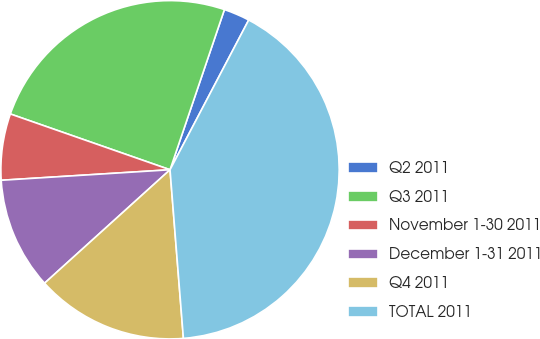<chart> <loc_0><loc_0><loc_500><loc_500><pie_chart><fcel>Q2 2011<fcel>Q3 2011<fcel>November 1-30 2011<fcel>December 1-31 2011<fcel>Q4 2011<fcel>TOTAL 2011<nl><fcel>2.49%<fcel>24.86%<fcel>6.34%<fcel>10.71%<fcel>14.56%<fcel>41.04%<nl></chart> 